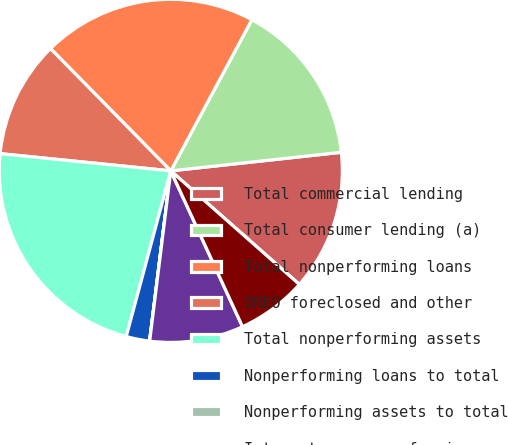Convert chart to OTSL. <chart><loc_0><loc_0><loc_500><loc_500><pie_chart><fcel>Total commercial lending<fcel>Total consumer lending (a)<fcel>Total nonperforming loans<fcel>OREO foreclosed and other<fcel>Total nonperforming assets<fcel>Nonperforming loans to total<fcel>Nonperforming assets to total<fcel>Interest on nonperforming<fcel>status (a) Excludes most<nl><fcel>13.24%<fcel>15.44%<fcel>20.21%<fcel>11.03%<fcel>22.42%<fcel>2.21%<fcel>0.01%<fcel>8.83%<fcel>6.62%<nl></chart> 